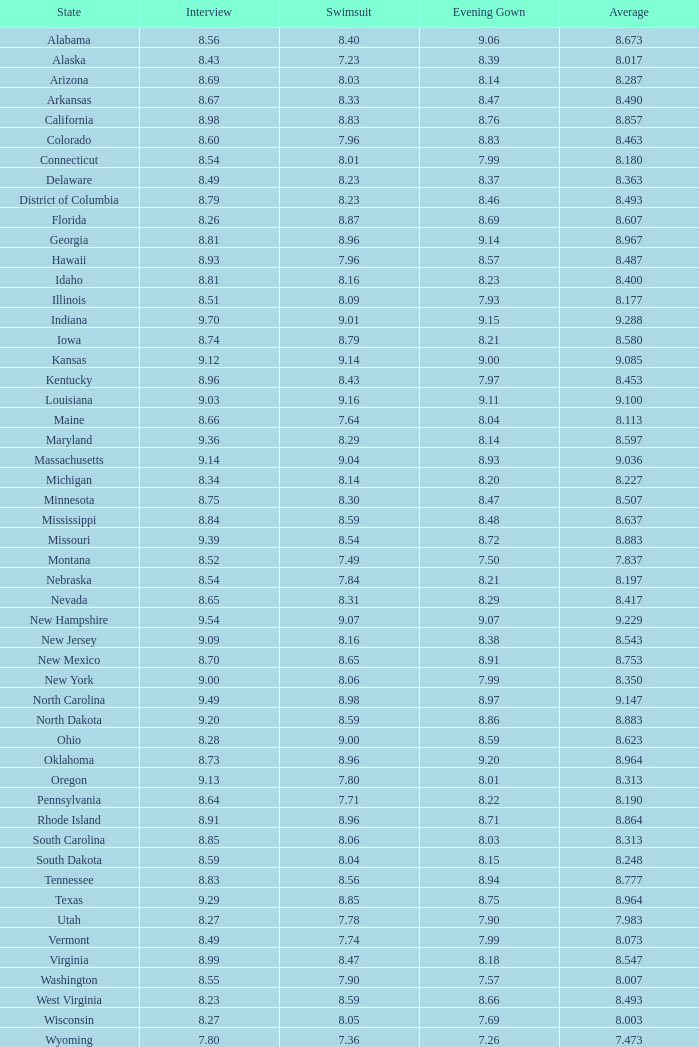7, and a swimsuit beneath Alabama. 